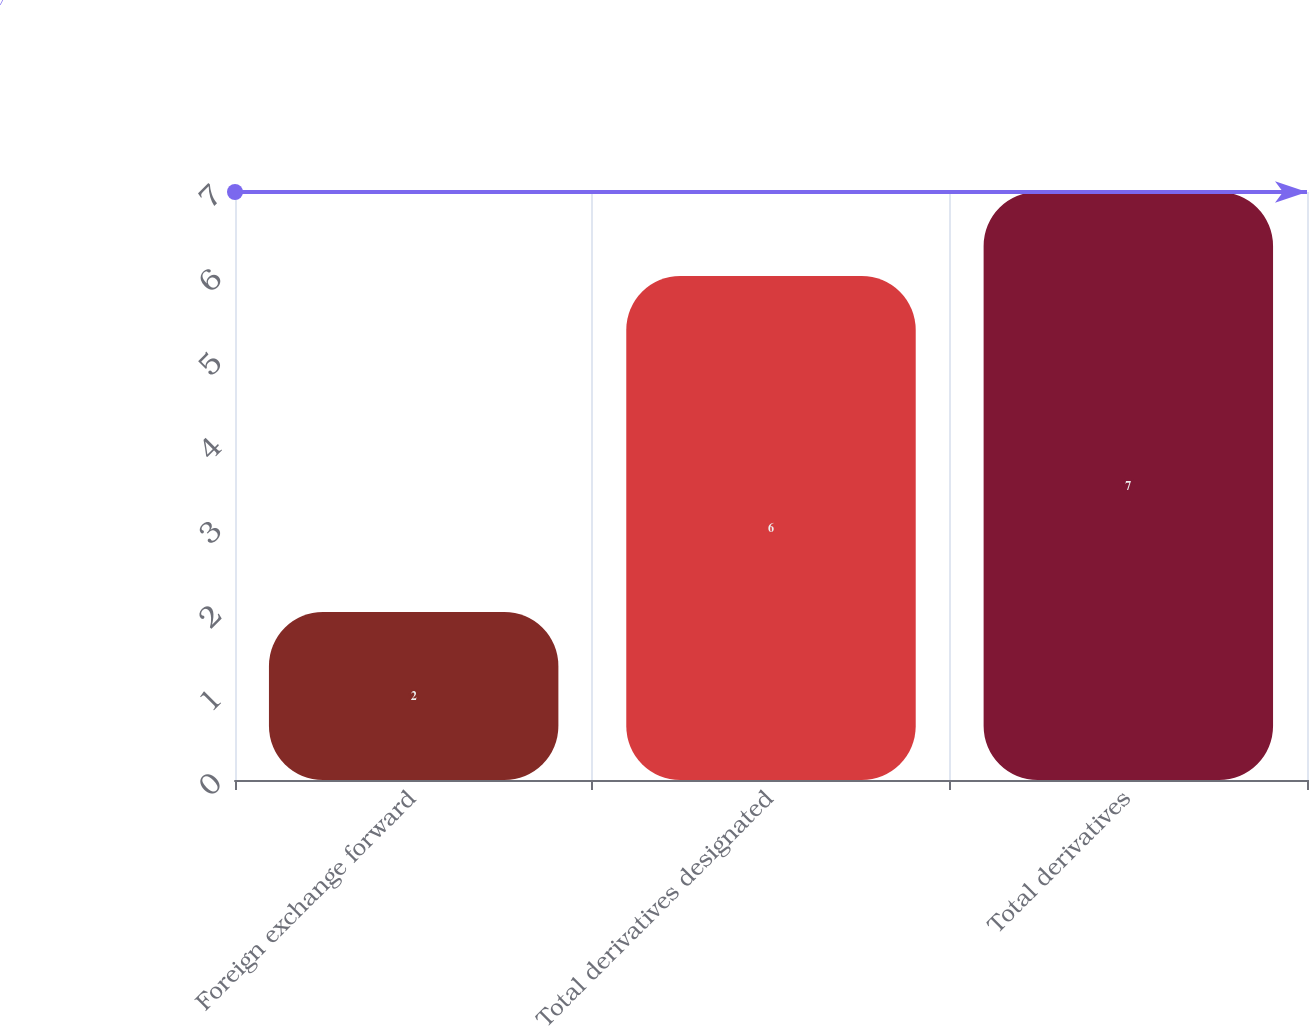Convert chart to OTSL. <chart><loc_0><loc_0><loc_500><loc_500><bar_chart><fcel>Foreign exchange forward<fcel>Total derivatives designated<fcel>Total derivatives<nl><fcel>2<fcel>6<fcel>7<nl></chart> 